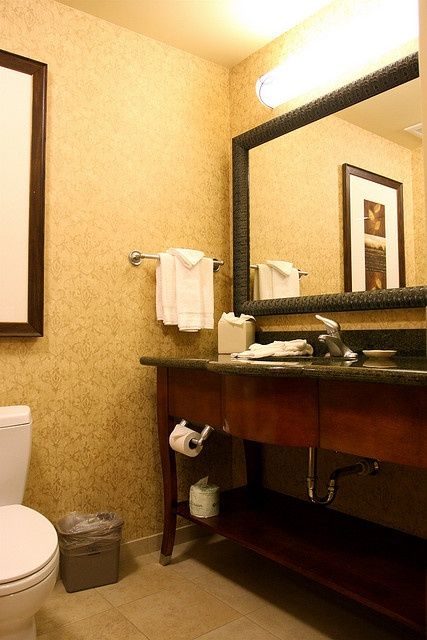Describe the objects in this image and their specific colors. I can see toilet in tan and olive tones, sink in tan, black, and olive tones, and sink in tan, black, and maroon tones in this image. 